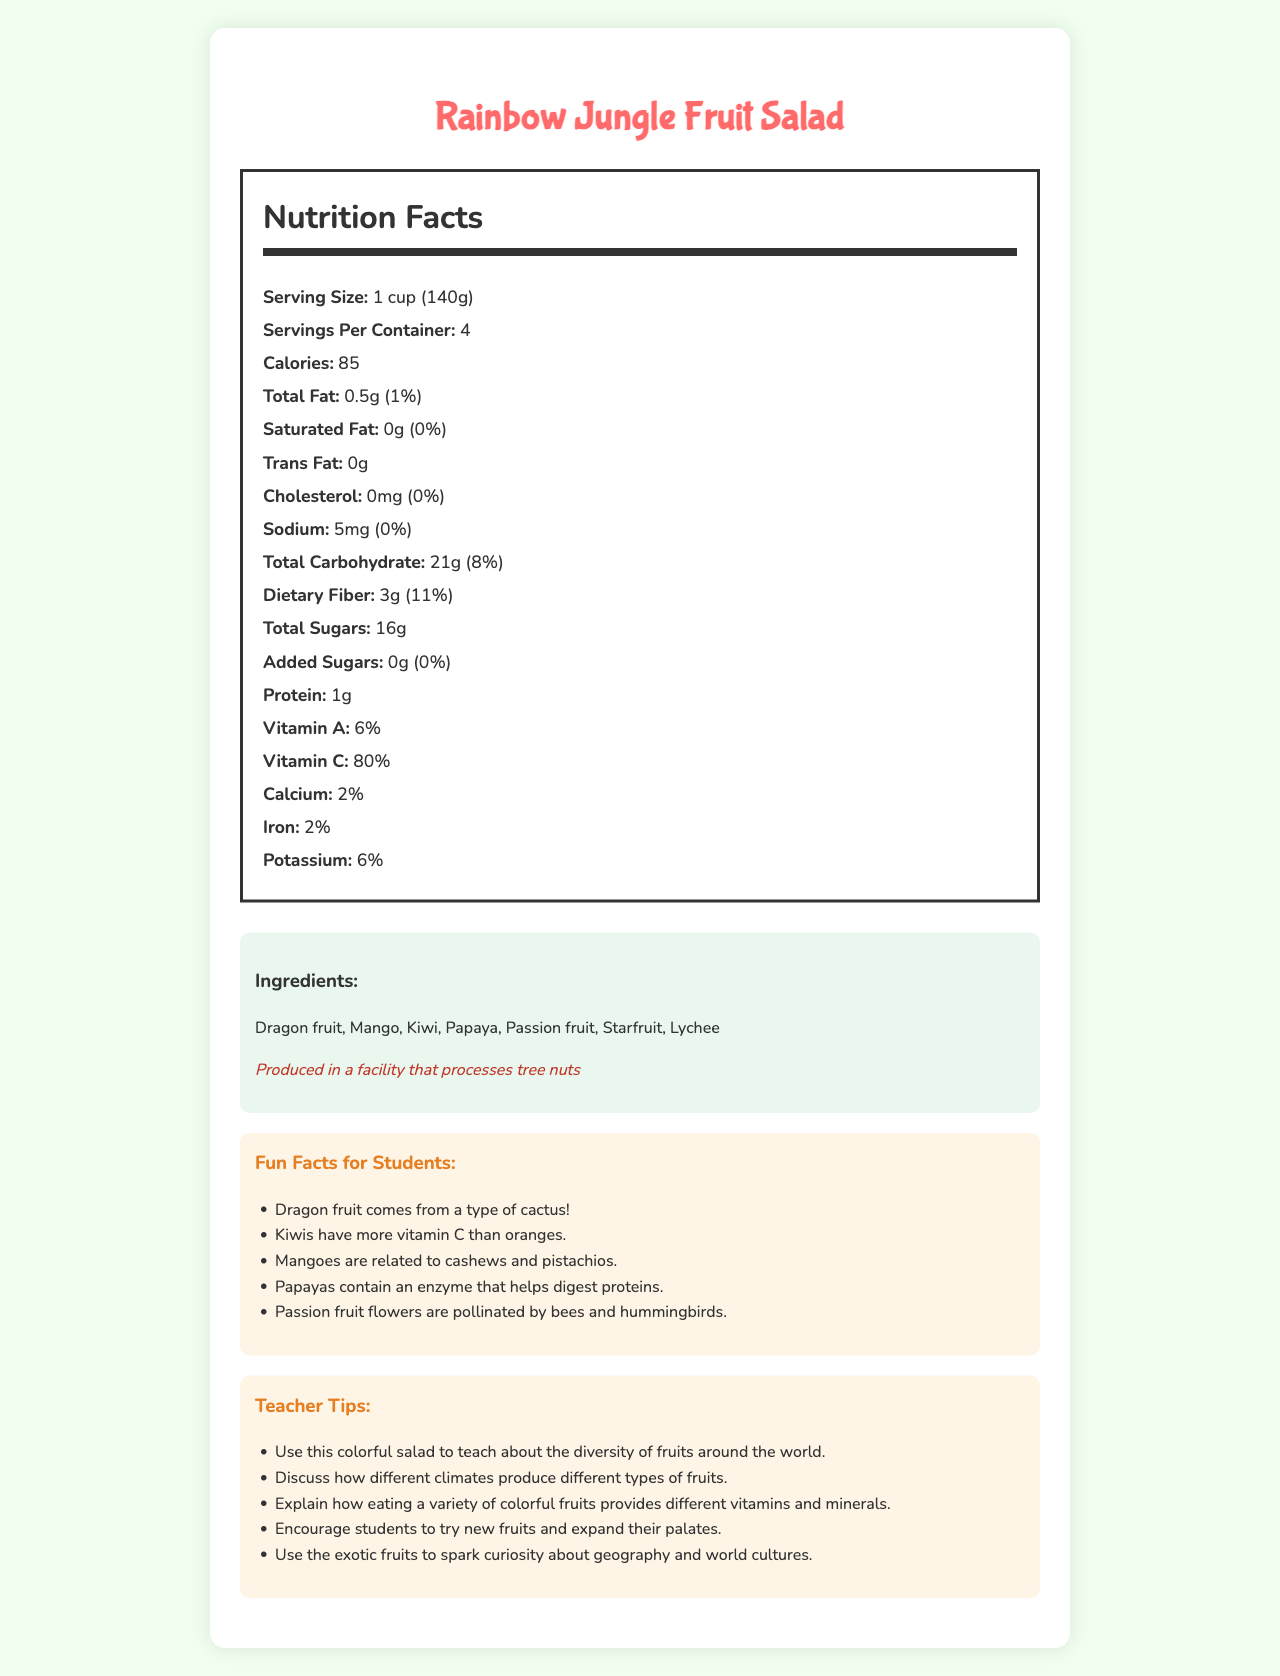what is the serving size of the Rainbow Jungle Fruit Salad? The serving size is explicitly mentioned in the nutrition label section of the document.
Answer: 1 cup (140g) how many servings are there per container? The number of servings per container is listed in the nutrition label section.
Answer: 4 how many calories are in one serving of the fruit salad? The calories per serving are stated within the nutrition facts.
Answer: 85 how much dietary fiber is in one serving of the fruit salad? Dietary fiber content per serving is detailed in the nutrition facts section.
Answer: 3g which vitamin has the highest percentage daily value in the fruit salad? According to the nutrition facts, Vitamin C has an 80% daily value, which is the highest among the listed vitamins.
Answer: Vitamin C how much protein does one serving of the fruit salad contain? The document specifically indicates that there is 1g of protein per serving.
Answer: 1g which of these fruits is not an ingredient in the fruit salad? A. Mango B. Banana C. Kiwi The listed ingredients include Mango and Kiwi, but not Banana.
Answer: B how much sodium is in one serving of the fruit salad? A. 5mg B. 10mg C. 15mg D. 20mg The nutrition label states that each serving contains 5mg of sodium.
Answer: A are there any added sugars in the fruit salad? The label indicates that there are 0g of added sugars in the fruit salad.
Answer: No is the fruit salad safe for someone with nut allergies? The allergen information states that it is produced in a facility that processes tree nuts.
Answer: No summarize the main idea of the document. The document is composed of sections that describe the product name, serving size, nutritional content, ingredients, allergen info, fun facts, and teacher tips, focusing on the educational and health aspects of the fruit salad.
Answer: The document provides detailed nutrition facts, ingredient list, and fun facts for the Rainbow Jungle Fruit Salad, highlighting its nutritional value, exotic ingredients, and health benefits. Additionally, it offers teacher tips to educate students about the diversity and benefits of fruits. what enzyme do papayas contain? The document mentions that papayas contain an enzyme that helps digest proteins but does not specify the enzyme's name.
Answer: Not enough information 